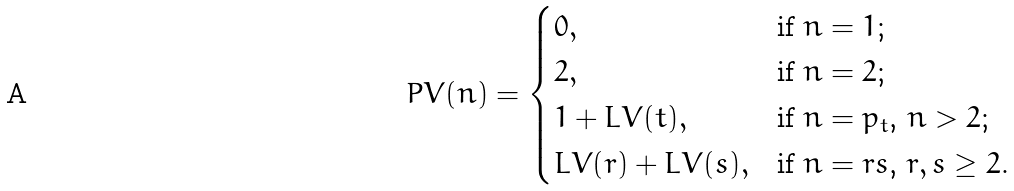<formula> <loc_0><loc_0><loc_500><loc_500>P V ( n ) = \begin{cases} 0 , & \text {if $n=1$;} \\ 2 , & \text {if $n=2$;} \\ 1 + L V ( t ) , & \text {if $n=p_{t}$, $n > 2$;} \\ L V ( r ) + L V ( s ) , & \text {if $n=rs$, $r,s \geq 2$. } \end{cases}</formula> 